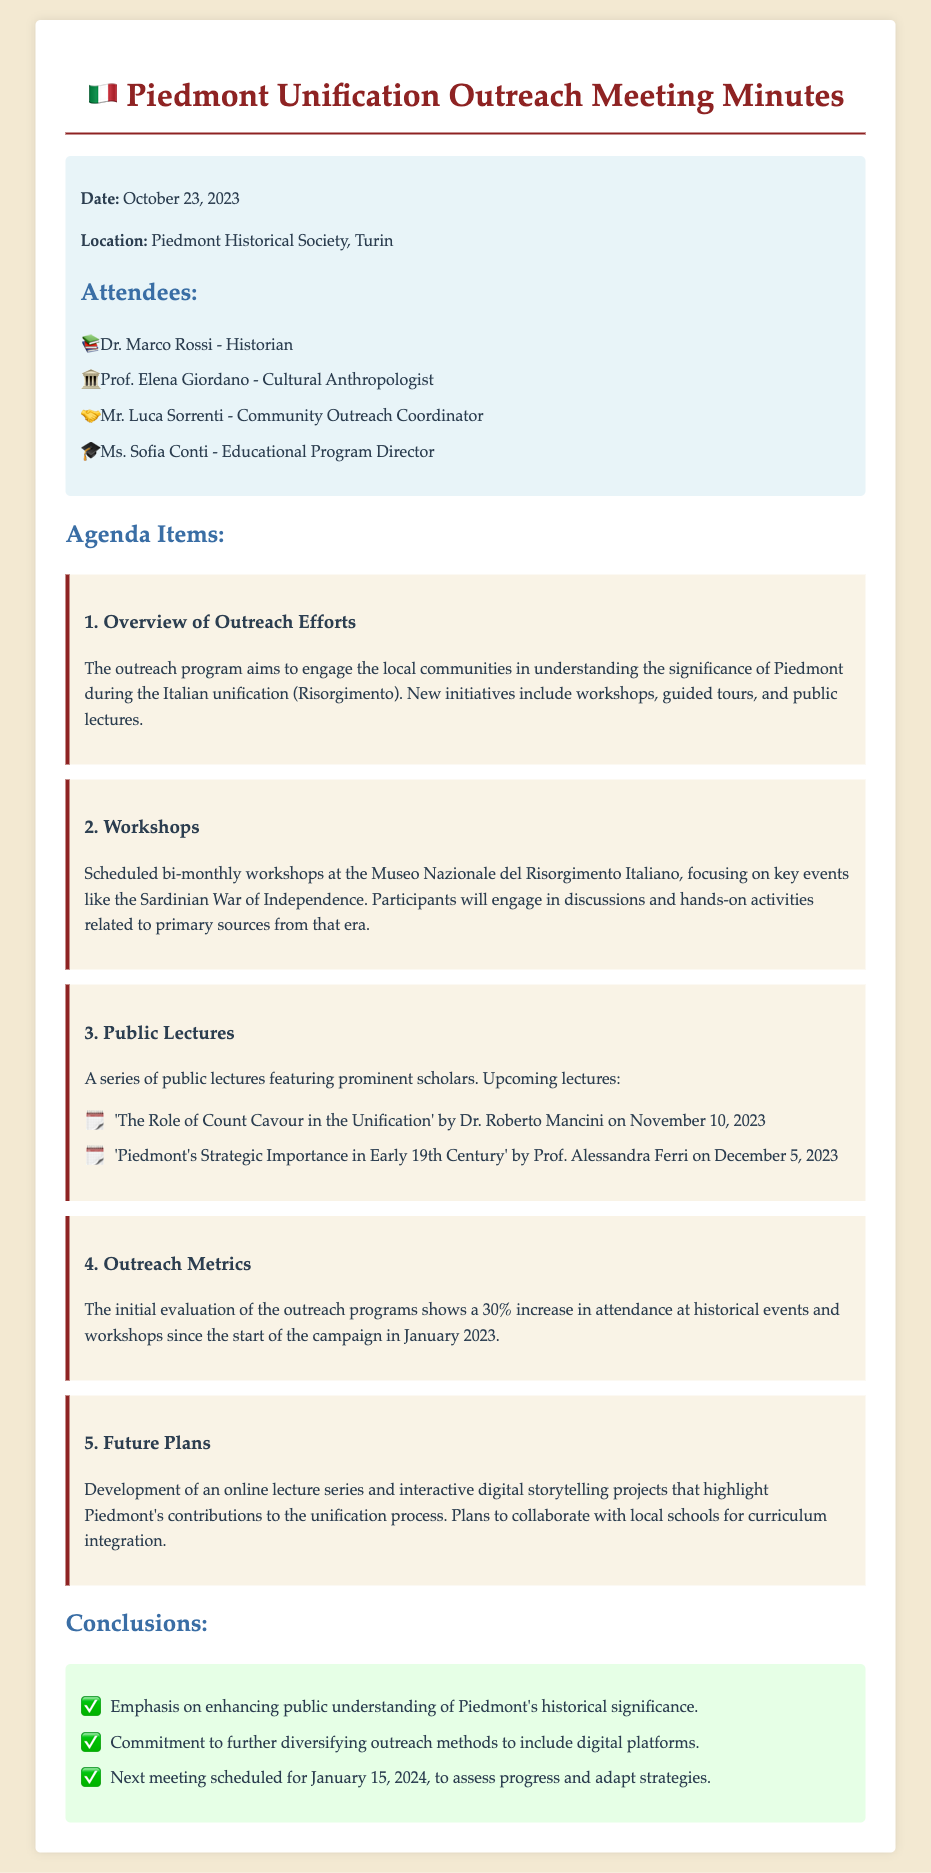what is the date of the meeting? The date of the meeting is stated in the document as October 23, 2023.
Answer: October 23, 2023 where was the meeting held? The document specifies that the location of the meeting was the Piedmont Historical Society, Turin.
Answer: Piedmont Historical Society, Turin who is scheduled to give a lecture on the role of Count Cavour? The document mentions that Dr. Roberto Mancini will give a lecture on this topic.
Answer: Dr. Roberto Mancini what percentage increase in attendance was noted since January 2023? The outreach metrics indicate a 30% increase in attendance at historical events since the campaign started.
Answer: 30% what type of new online initiative is planned for the future? The document mentions the development of an online lecture series as one of the future plans.
Answer: online lecture series how often are the workshops scheduled? The document states that the workshops are scheduled bi-monthly.
Answer: bi-monthly what is the major focus of the workshops? The document describes that the workshops focus on key events like the Sardinian War of Independence.
Answer: Sardinian War of Independence when is the next meeting scheduled? The document specifies that the next meeting is scheduled for January 15, 2024.
Answer: January 15, 2024 